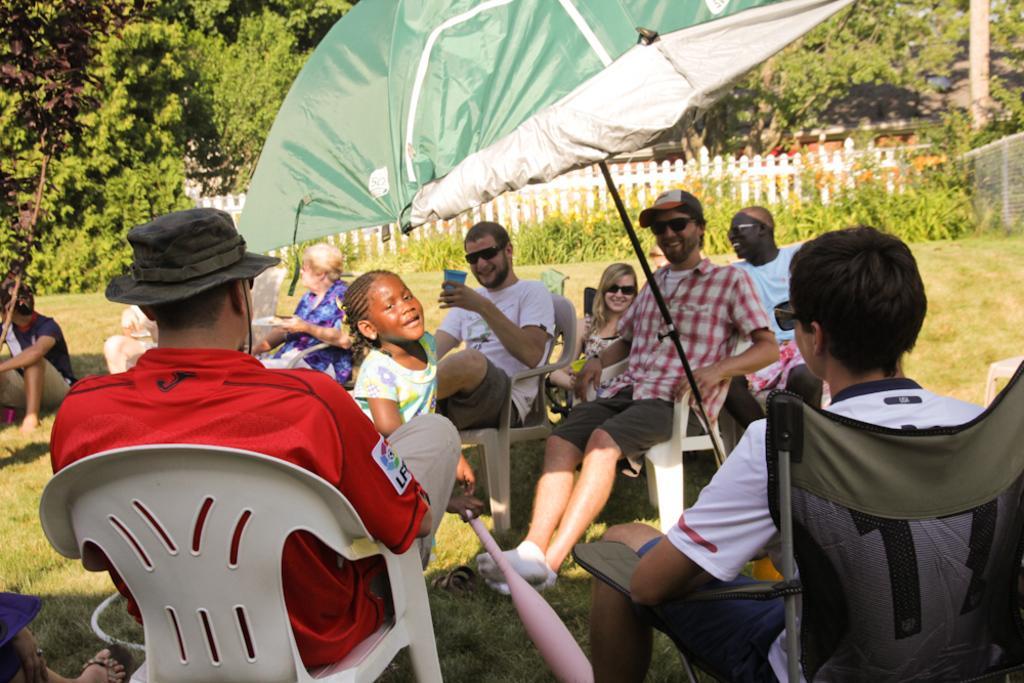Could you give a brief overview of what you see in this image? This picture is clicked outside. In the center we can see the group of people sitting on the chairs and there is a kid holding an object and standing on the ground and we can see an umbrella. In the background there is a person sitting on the ground and we can see the trees, fence, building and plants. 